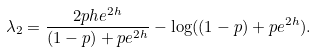Convert formula to latex. <formula><loc_0><loc_0><loc_500><loc_500>\lambda _ { 2 } = \frac { 2 p h e ^ { 2 h } } { ( 1 - p ) + p e ^ { 2 h } } - \log ( ( 1 - p ) + p e ^ { 2 h } ) .</formula> 